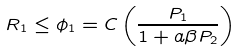Convert formula to latex. <formula><loc_0><loc_0><loc_500><loc_500>R _ { 1 } \leq \phi _ { 1 } = C \left ( \frac { P _ { 1 } } { 1 + a \beta P _ { 2 } } \right )</formula> 